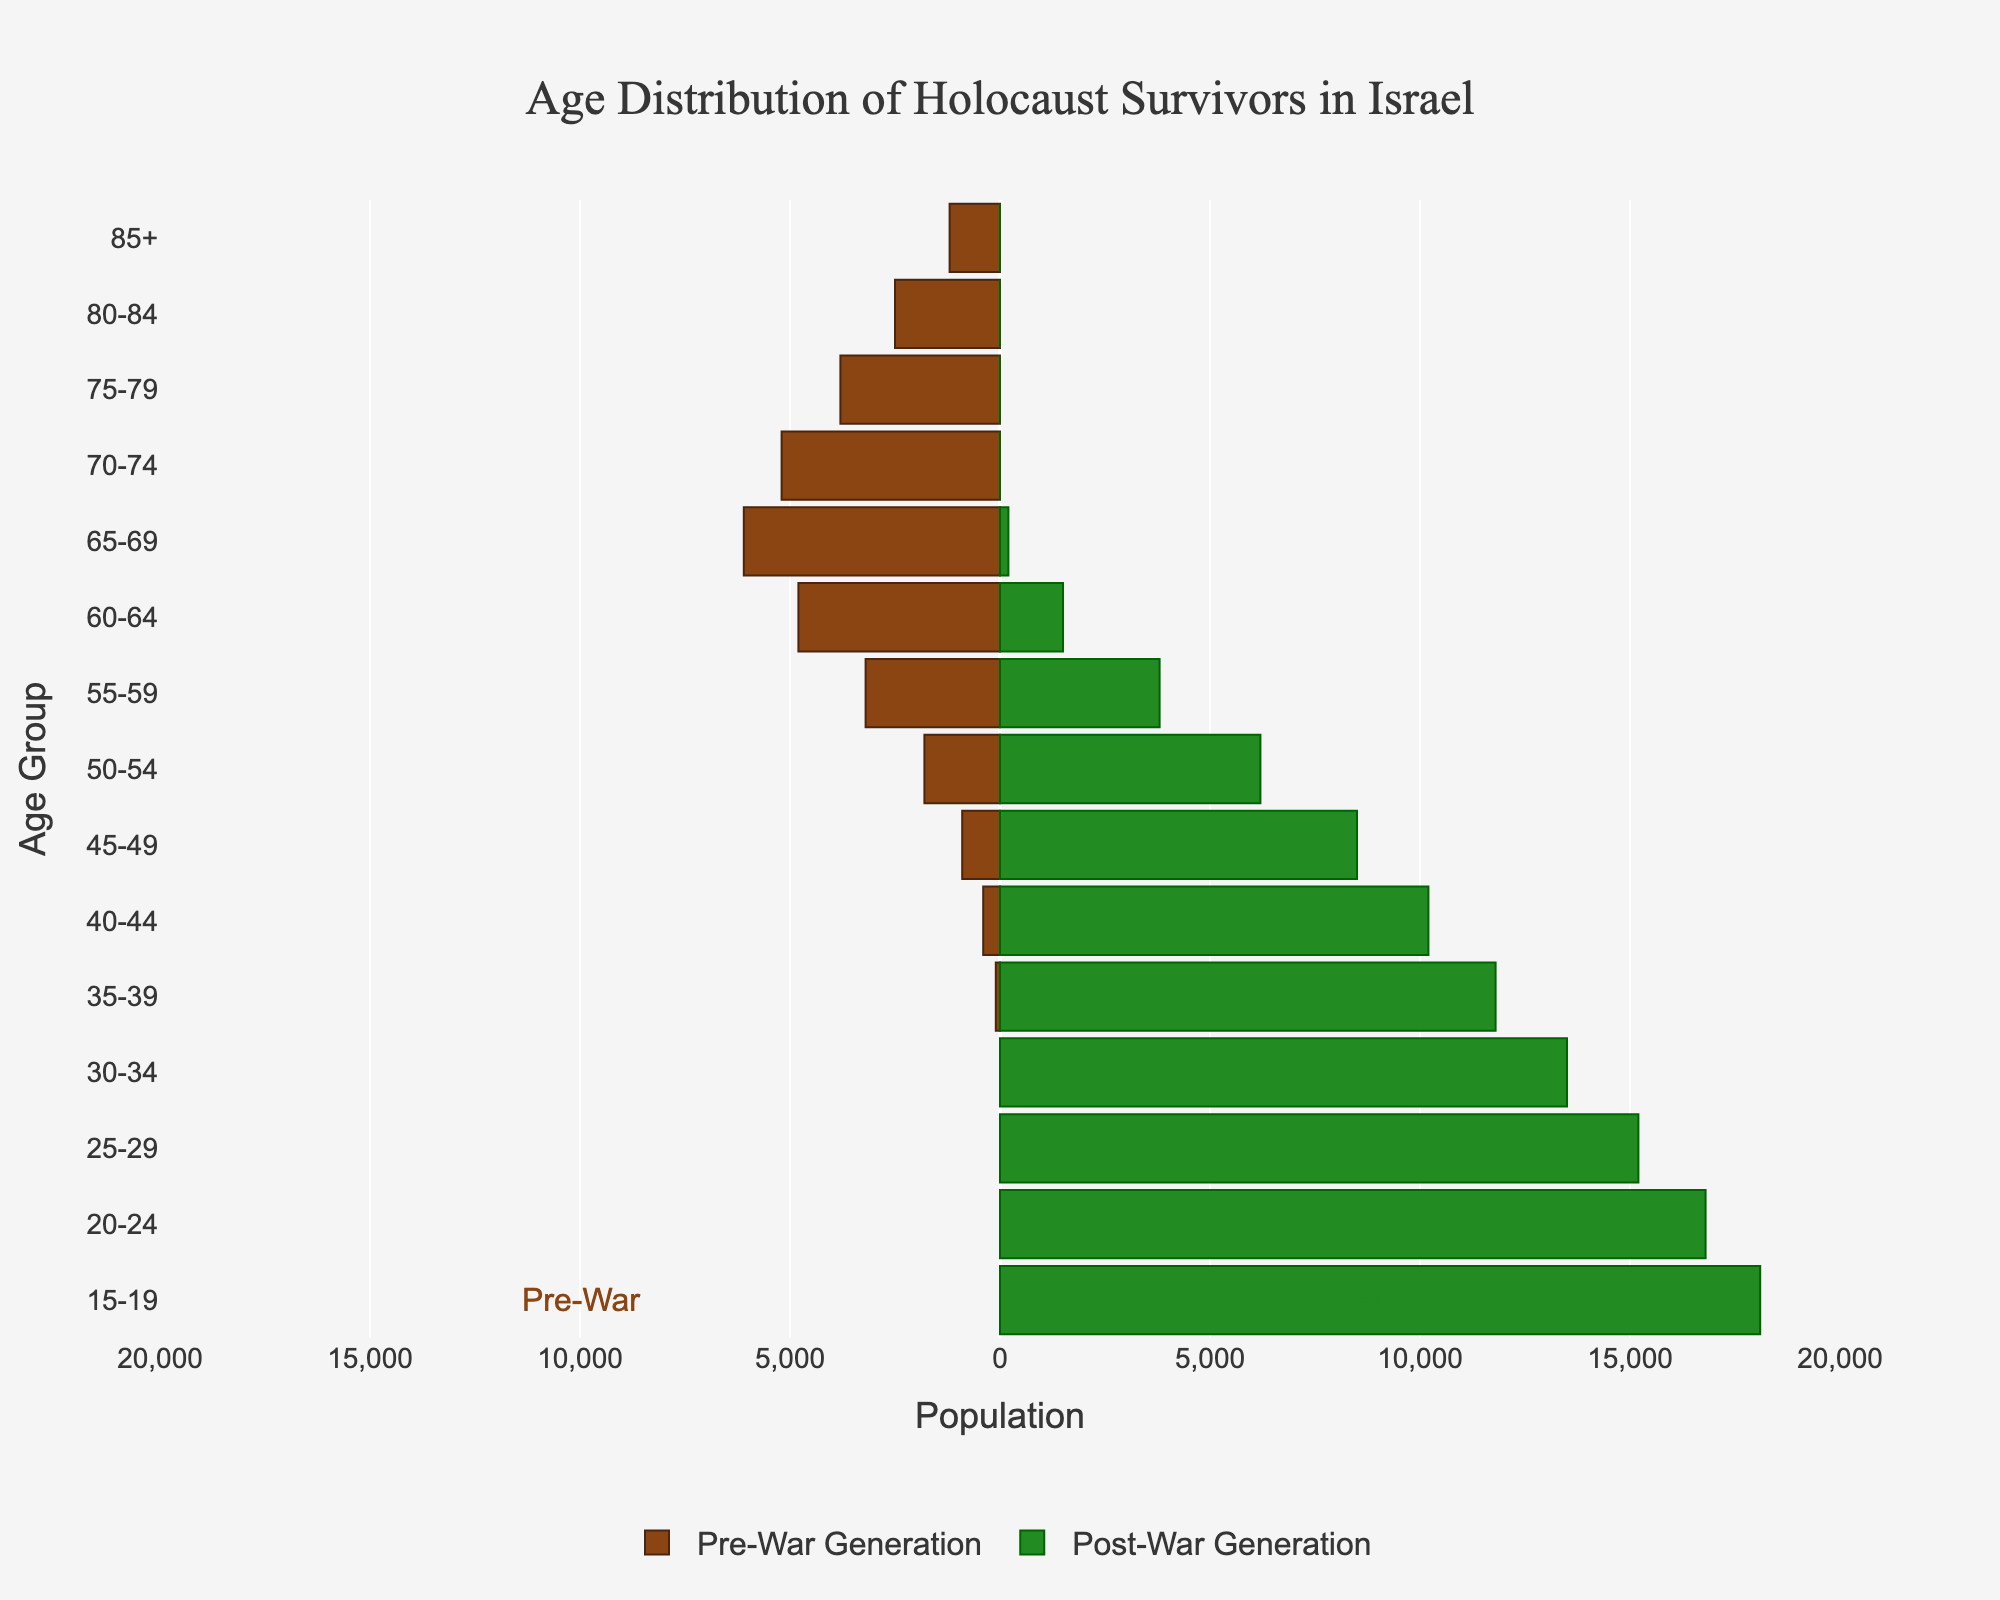What is the title of the figure? The title is typically found at the top of the chart and clearly describes what the figure represents. The title in this figure is centered at the top.
Answer: Age Distribution of Holocaust Survivors in Israel Which age group has the highest population in the post-war generation? To determine this, look at the longest bar on the post-war side (right side) of the figure.
Answer: 15-19 Are there any age groups in the pre-war generation with zero population? This can be answered by checking for any bars on the left side of the figure that do not extend from zero. The 30-34 and younger age groups show zeros for the pre-war generation.
Answer: Yes For the age group 60-64, which generation has a higher population? Compare the lengths of the bars for the 60-64 age group on both sides of the figure. The right side represents the post-war generation and the left side represents the pre-war generation.
Answer: Pre-War Generation Which color represents the pre-war generation? The legend at the bottom of the figure indicates which color corresponds to each generation. The pre-war generation is represented by brownish color.
Answer: Brown What is the population difference between pre-war and post-war generations in the age group 55-59? Look at the bars for the age group 55-59 on both sides of the figure, subtract the pre-war population from the post-war population. The pre-war population is 3200 and the post-war population is 3800. Calculate 3800 - 3200 = 600.
Answer: 600 Which age group has the smallest population in the pre-war generation? Identify the shortest bar on the left side of the figure, where the pre-war generation is displayed. The age group 35-39 has the shortest bar.
Answer: 35-39 How does the population of the age group 80-84 compare between the two generations? Evaluate the bars for the age group 80-84 on both sides of the figure. The pre-war generation has a population, while the post-war generation does not, so the pre-war population is greater.
Answer: Pre-war generation is greater What is the total population of the 70-74 age group across both generations? Summing the values of both groups for the 70-74 age group from the figure: 5200 (pre-war) + 0 (post-war) = 5200.
Answer: 5200 In which generation is the age group 25-29 found? Observe which side of the figure contains bars for the age group 25-29. It is on the post-war side (right side).
Answer: Post-War Generation 